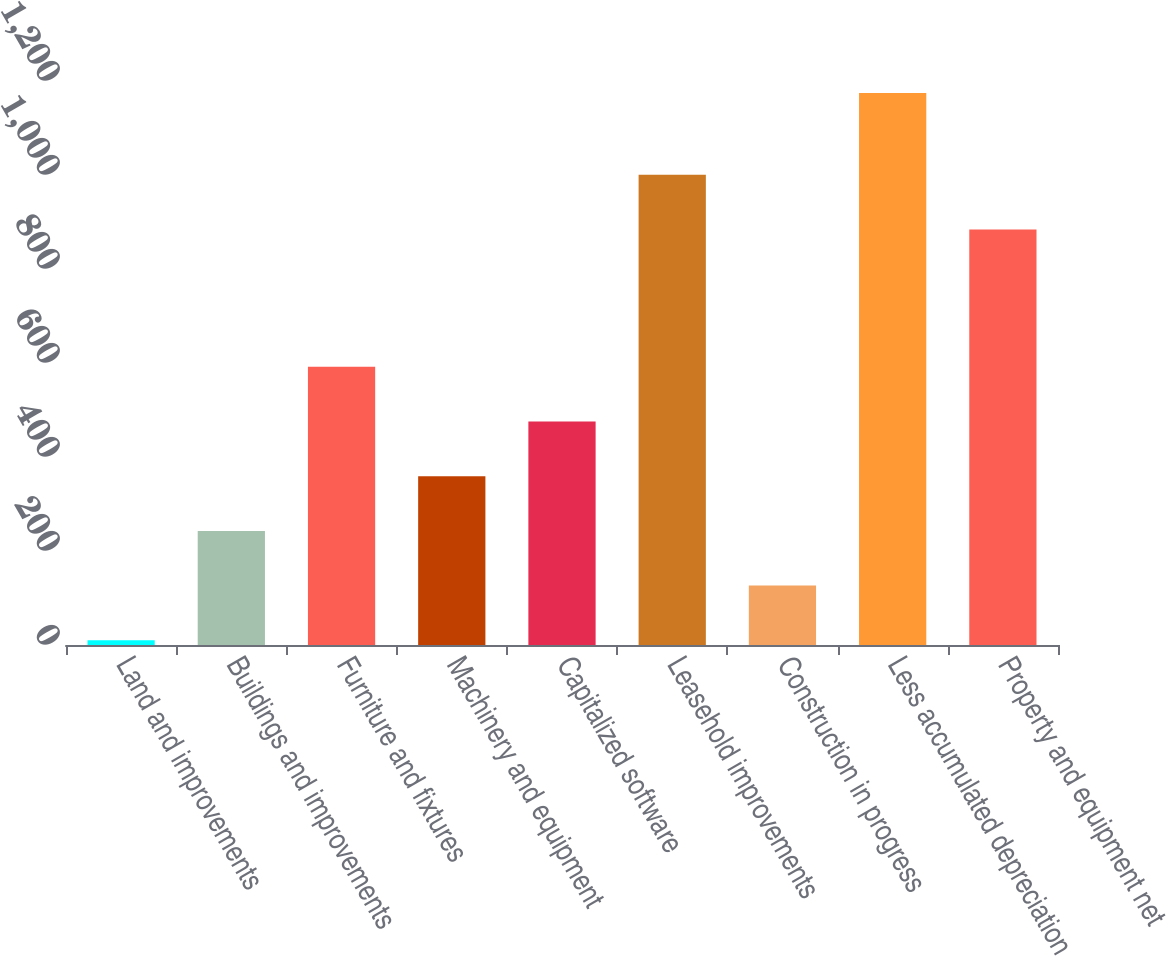Convert chart to OTSL. <chart><loc_0><loc_0><loc_500><loc_500><bar_chart><fcel>Land and improvements<fcel>Buildings and improvements<fcel>Furniture and fixtures<fcel>Machinery and equipment<fcel>Capitalized software<fcel>Leasehold improvements<fcel>Construction in progress<fcel>Less accumulated depreciation<fcel>Property and equipment net<nl><fcel>9.9<fcel>242.8<fcel>592.15<fcel>359.25<fcel>475.7<fcel>1000.55<fcel>126.35<fcel>1174.4<fcel>884.1<nl></chart> 